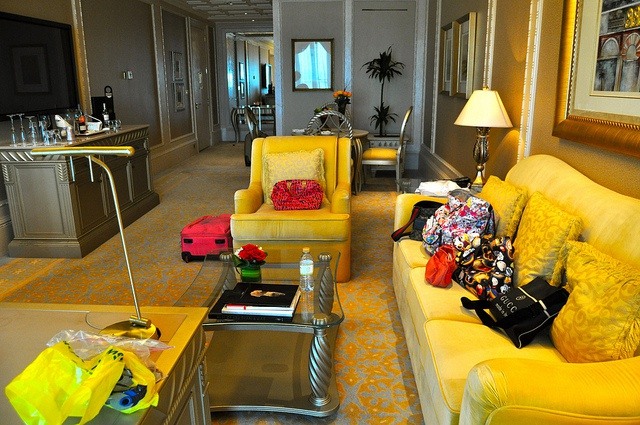Describe the objects in this image and their specific colors. I can see couch in black, orange, and gold tones, chair in black, orange, olive, gold, and tan tones, tv in black and gray tones, handbag in black, gray, and olive tones, and backpack in black, white, darkgray, and gray tones in this image. 